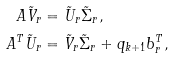<formula> <loc_0><loc_0><loc_500><loc_500>A \tilde { V } _ { r } & = \tilde { U } _ { r } \tilde { \Sigma } _ { r } , \\ A ^ { T } \tilde { U } _ { r } & = \tilde { V } _ { r } \tilde { \Sigma } _ { r } + q _ { k + 1 } b _ { r } ^ { T } ,</formula> 